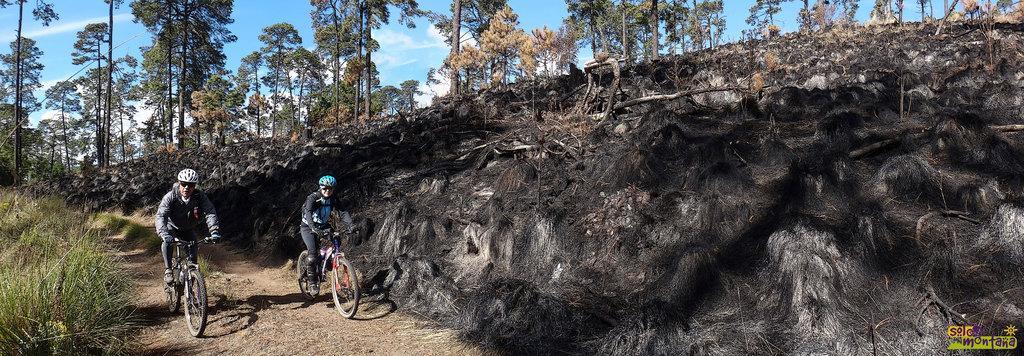Could you give a brief overview of what you see in this image? In the foreground I can see two persons are riding a bicycle on the ground. In the background I can see mountains, grass, trees and the sky. This image is taken during a day. 